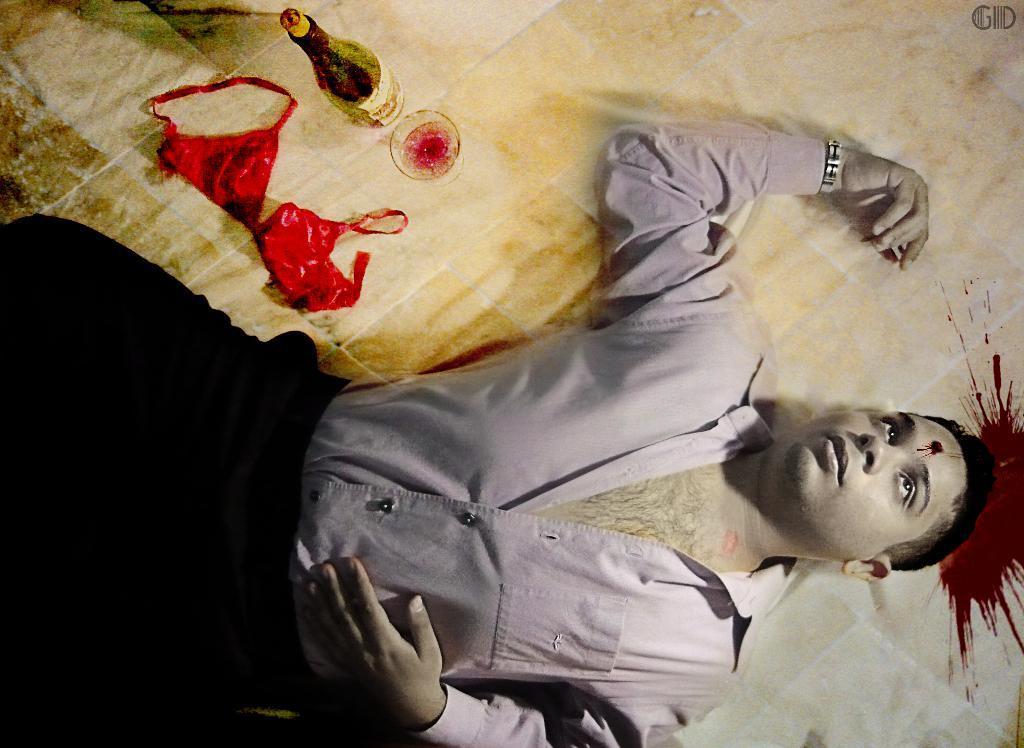How would you summarize this image in a sentence or two? In this image we can see a man lying on the floor and on the floor we can see the blood, a bottle, glass and also the inner wear of a woman. 